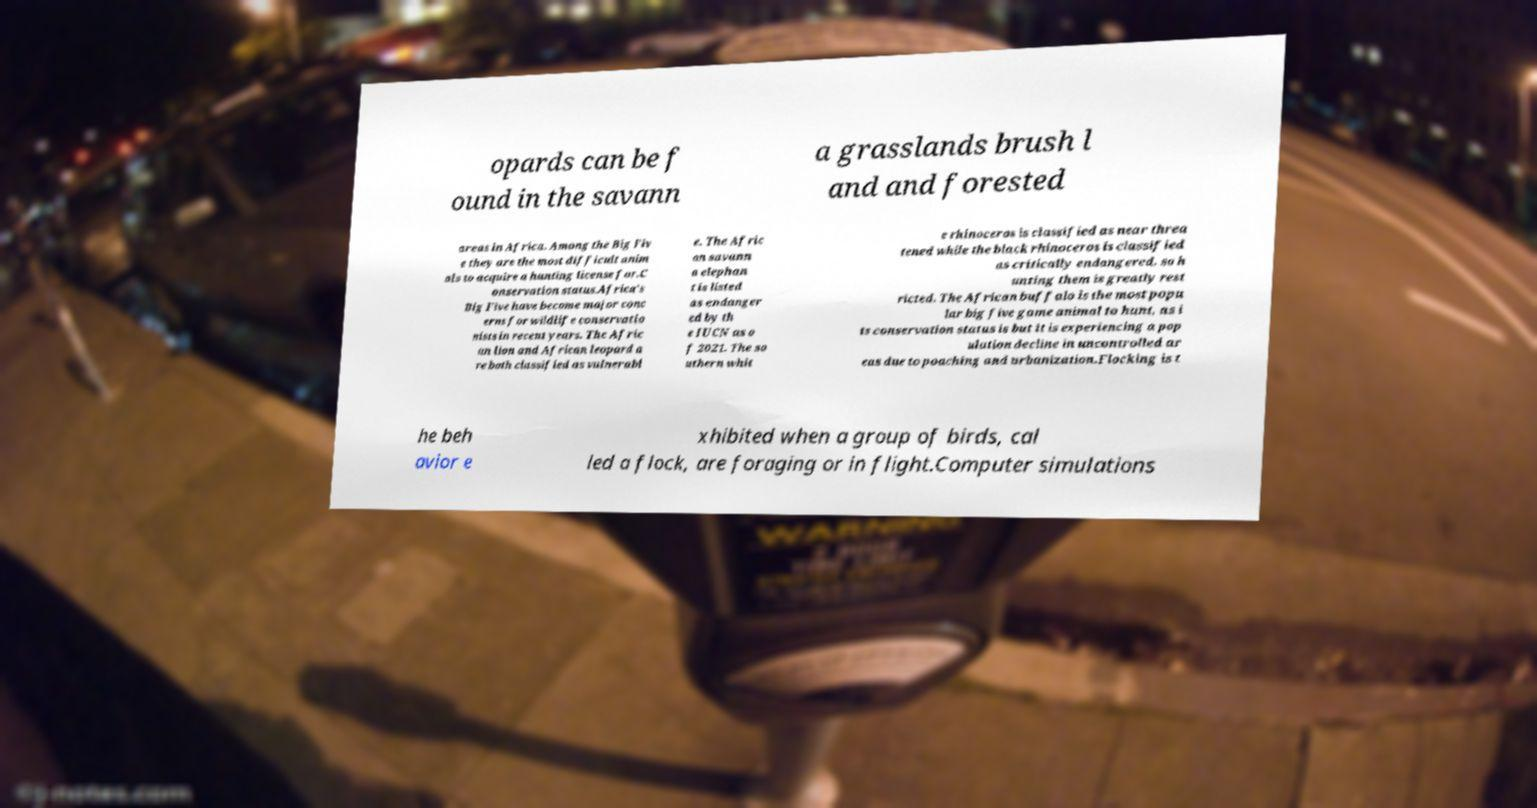What messages or text are displayed in this image? I need them in a readable, typed format. opards can be f ound in the savann a grasslands brush l and and forested areas in Africa. Among the Big Fiv e they are the most difficult anim als to acquire a hunting license for.C onservation status.Africa's Big Five have become major conc erns for wildlife conservatio nists in recent years. The Afric an lion and African leopard a re both classified as vulnerabl e. The Afric an savann a elephan t is listed as endanger ed by th e IUCN as o f 2021. The so uthern whit e rhinoceros is classified as near threa tened while the black rhinoceros is classified as critically endangered, so h unting them is greatly rest ricted. The African buffalo is the most popu lar big five game animal to hunt, as i ts conservation status is but it is experiencing a pop ulation decline in uncontrolled ar eas due to poaching and urbanization.Flocking is t he beh avior e xhibited when a group of birds, cal led a flock, are foraging or in flight.Computer simulations 